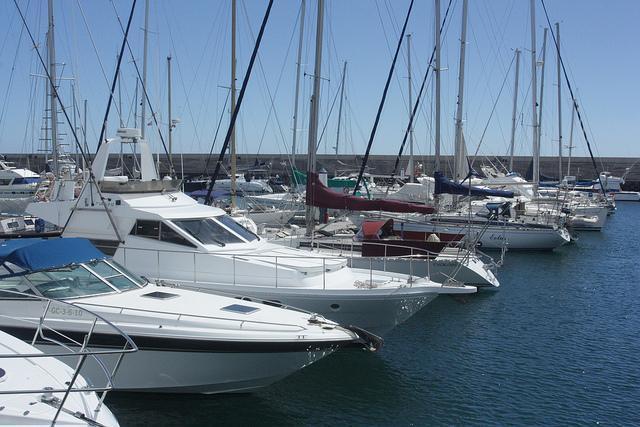How many boats are there?
Give a very brief answer. 6. How many blue airplanes are in the image?
Give a very brief answer. 0. 